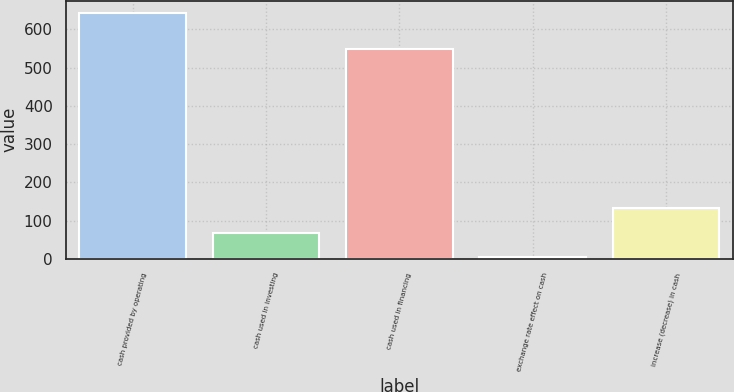Convert chart. <chart><loc_0><loc_0><loc_500><loc_500><bar_chart><fcel>cash provided by operating<fcel>cash used in investing<fcel>cash used in financing<fcel>exchange rate effect on cash<fcel>increase (decrease) in cash<nl><fcel>643.4<fcel>68.03<fcel>550.1<fcel>4.1<fcel>131.96<nl></chart> 